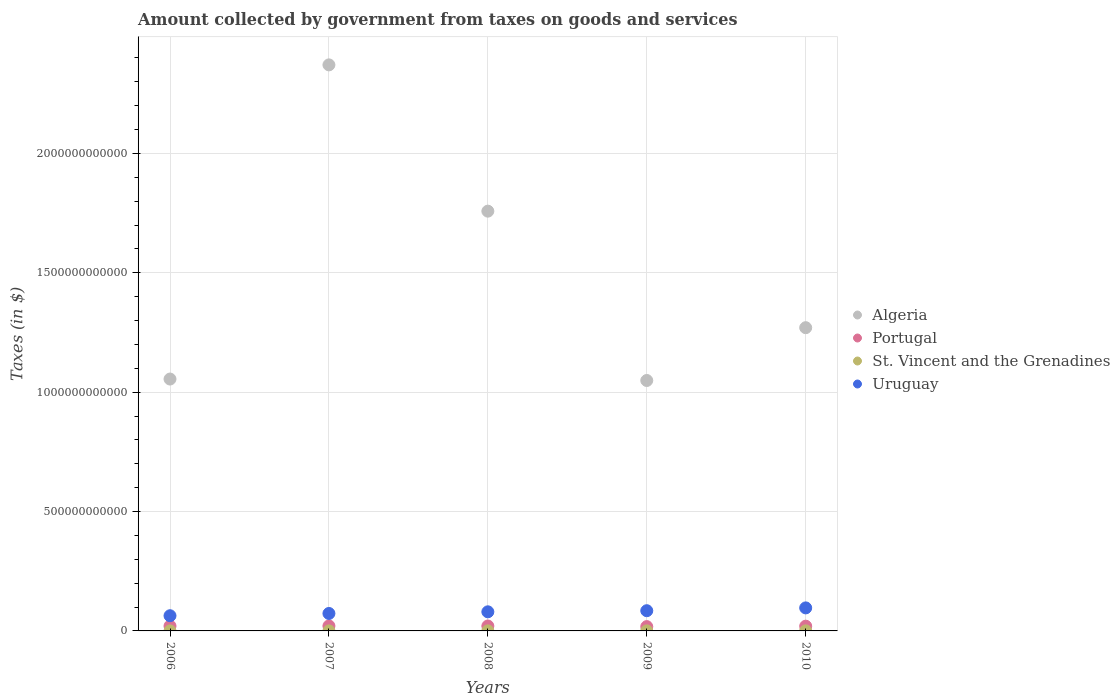How many different coloured dotlines are there?
Offer a terse response. 4. Is the number of dotlines equal to the number of legend labels?
Provide a succinct answer. Yes. What is the amount collected by government from taxes on goods and services in Portugal in 2010?
Provide a succinct answer. 1.99e+1. Across all years, what is the maximum amount collected by government from taxes on goods and services in St. Vincent and the Grenadines?
Provide a short and direct response. 2.46e+08. Across all years, what is the minimum amount collected by government from taxes on goods and services in St. Vincent and the Grenadines?
Give a very brief answer. 9.81e+07. In which year was the amount collected by government from taxes on goods and services in Algeria minimum?
Your answer should be very brief. 2009. What is the total amount collected by government from taxes on goods and services in St. Vincent and the Grenadines in the graph?
Provide a short and direct response. 9.94e+08. What is the difference between the amount collected by government from taxes on goods and services in Algeria in 2006 and that in 2010?
Offer a terse response. -2.15e+11. What is the difference between the amount collected by government from taxes on goods and services in Uruguay in 2007 and the amount collected by government from taxes on goods and services in Algeria in 2008?
Offer a very short reply. -1.69e+12. What is the average amount collected by government from taxes on goods and services in Uruguay per year?
Your answer should be compact. 7.96e+1. In the year 2008, what is the difference between the amount collected by government from taxes on goods and services in Uruguay and amount collected by government from taxes on goods and services in Algeria?
Provide a short and direct response. -1.68e+12. What is the ratio of the amount collected by government from taxes on goods and services in Algeria in 2009 to that in 2010?
Your answer should be very brief. 0.83. Is the difference between the amount collected by government from taxes on goods and services in Uruguay in 2006 and 2007 greater than the difference between the amount collected by government from taxes on goods and services in Algeria in 2006 and 2007?
Make the answer very short. Yes. What is the difference between the highest and the second highest amount collected by government from taxes on goods and services in Portugal?
Offer a terse response. 2.85e+08. What is the difference between the highest and the lowest amount collected by government from taxes on goods and services in St. Vincent and the Grenadines?
Make the answer very short. 1.48e+08. In how many years, is the amount collected by government from taxes on goods and services in St. Vincent and the Grenadines greater than the average amount collected by government from taxes on goods and services in St. Vincent and the Grenadines taken over all years?
Make the answer very short. 3. Does the amount collected by government from taxes on goods and services in Portugal monotonically increase over the years?
Make the answer very short. No. Is the amount collected by government from taxes on goods and services in Algeria strictly greater than the amount collected by government from taxes on goods and services in Uruguay over the years?
Ensure brevity in your answer.  Yes. Is the amount collected by government from taxes on goods and services in Portugal strictly less than the amount collected by government from taxes on goods and services in St. Vincent and the Grenadines over the years?
Your answer should be very brief. No. How many years are there in the graph?
Offer a terse response. 5. What is the difference between two consecutive major ticks on the Y-axis?
Make the answer very short. 5.00e+11. Are the values on the major ticks of Y-axis written in scientific E-notation?
Keep it short and to the point. No. Where does the legend appear in the graph?
Keep it short and to the point. Center right. How many legend labels are there?
Keep it short and to the point. 4. What is the title of the graph?
Offer a terse response. Amount collected by government from taxes on goods and services. What is the label or title of the Y-axis?
Offer a very short reply. Taxes (in $). What is the Taxes (in $) of Algeria in 2006?
Provide a succinct answer. 1.05e+12. What is the Taxes (in $) of Portugal in 2006?
Your answer should be very brief. 2.04e+1. What is the Taxes (in $) in St. Vincent and the Grenadines in 2006?
Your answer should be compact. 9.81e+07. What is the Taxes (in $) of Uruguay in 2006?
Make the answer very short. 6.36e+1. What is the Taxes (in $) of Algeria in 2007?
Make the answer very short. 2.37e+12. What is the Taxes (in $) of Portugal in 2007?
Your response must be concise. 2.09e+1. What is the Taxes (in $) in St. Vincent and the Grenadines in 2007?
Give a very brief answer. 1.85e+08. What is the Taxes (in $) in Uruguay in 2007?
Give a very brief answer. 7.31e+1. What is the Taxes (in $) in Algeria in 2008?
Ensure brevity in your answer.  1.76e+12. What is the Taxes (in $) in Portugal in 2008?
Give a very brief answer. 2.06e+1. What is the Taxes (in $) of St. Vincent and the Grenadines in 2008?
Your answer should be very brief. 2.46e+08. What is the Taxes (in $) of Uruguay in 2008?
Offer a terse response. 8.00e+1. What is the Taxes (in $) in Algeria in 2009?
Ensure brevity in your answer.  1.05e+12. What is the Taxes (in $) of Portugal in 2009?
Ensure brevity in your answer.  1.81e+1. What is the Taxes (in $) in St. Vincent and the Grenadines in 2009?
Ensure brevity in your answer.  2.37e+08. What is the Taxes (in $) of Uruguay in 2009?
Keep it short and to the point. 8.47e+1. What is the Taxes (in $) of Algeria in 2010?
Keep it short and to the point. 1.27e+12. What is the Taxes (in $) of Portugal in 2010?
Keep it short and to the point. 1.99e+1. What is the Taxes (in $) in St. Vincent and the Grenadines in 2010?
Your answer should be very brief. 2.28e+08. What is the Taxes (in $) of Uruguay in 2010?
Provide a short and direct response. 9.64e+1. Across all years, what is the maximum Taxes (in $) of Algeria?
Provide a short and direct response. 2.37e+12. Across all years, what is the maximum Taxes (in $) of Portugal?
Your answer should be very brief. 2.09e+1. Across all years, what is the maximum Taxes (in $) in St. Vincent and the Grenadines?
Ensure brevity in your answer.  2.46e+08. Across all years, what is the maximum Taxes (in $) of Uruguay?
Offer a terse response. 9.64e+1. Across all years, what is the minimum Taxes (in $) of Algeria?
Offer a terse response. 1.05e+12. Across all years, what is the minimum Taxes (in $) of Portugal?
Your answer should be compact. 1.81e+1. Across all years, what is the minimum Taxes (in $) of St. Vincent and the Grenadines?
Keep it short and to the point. 9.81e+07. Across all years, what is the minimum Taxes (in $) of Uruguay?
Your answer should be very brief. 6.36e+1. What is the total Taxes (in $) of Algeria in the graph?
Your answer should be compact. 7.50e+12. What is the total Taxes (in $) of Portugal in the graph?
Your answer should be very brief. 9.99e+1. What is the total Taxes (in $) of St. Vincent and the Grenadines in the graph?
Ensure brevity in your answer.  9.94e+08. What is the total Taxes (in $) of Uruguay in the graph?
Your answer should be compact. 3.98e+11. What is the difference between the Taxes (in $) in Algeria in 2006 and that in 2007?
Give a very brief answer. -1.32e+12. What is the difference between the Taxes (in $) of Portugal in 2006 and that in 2007?
Offer a terse response. -4.60e+08. What is the difference between the Taxes (in $) in St. Vincent and the Grenadines in 2006 and that in 2007?
Your answer should be compact. -8.72e+07. What is the difference between the Taxes (in $) in Uruguay in 2006 and that in 2007?
Provide a succinct answer. -9.46e+09. What is the difference between the Taxes (in $) of Algeria in 2006 and that in 2008?
Ensure brevity in your answer.  -7.03e+11. What is the difference between the Taxes (in $) in Portugal in 2006 and that in 2008?
Ensure brevity in your answer.  -1.75e+08. What is the difference between the Taxes (in $) of St. Vincent and the Grenadines in 2006 and that in 2008?
Keep it short and to the point. -1.48e+08. What is the difference between the Taxes (in $) of Uruguay in 2006 and that in 2008?
Offer a terse response. -1.64e+1. What is the difference between the Taxes (in $) of Algeria in 2006 and that in 2009?
Give a very brief answer. 6.04e+09. What is the difference between the Taxes (in $) of Portugal in 2006 and that in 2009?
Offer a very short reply. 2.35e+09. What is the difference between the Taxes (in $) of St. Vincent and the Grenadines in 2006 and that in 2009?
Ensure brevity in your answer.  -1.39e+08. What is the difference between the Taxes (in $) of Uruguay in 2006 and that in 2009?
Provide a succinct answer. -2.10e+1. What is the difference between the Taxes (in $) of Algeria in 2006 and that in 2010?
Your response must be concise. -2.15e+11. What is the difference between the Taxes (in $) of Portugal in 2006 and that in 2010?
Your answer should be compact. 5.46e+08. What is the difference between the Taxes (in $) in St. Vincent and the Grenadines in 2006 and that in 2010?
Provide a succinct answer. -1.30e+08. What is the difference between the Taxes (in $) of Uruguay in 2006 and that in 2010?
Provide a succinct answer. -3.28e+1. What is the difference between the Taxes (in $) in Algeria in 2007 and that in 2008?
Your answer should be very brief. 6.13e+11. What is the difference between the Taxes (in $) in Portugal in 2007 and that in 2008?
Provide a short and direct response. 2.85e+08. What is the difference between the Taxes (in $) of St. Vincent and the Grenadines in 2007 and that in 2008?
Provide a succinct answer. -6.05e+07. What is the difference between the Taxes (in $) of Uruguay in 2007 and that in 2008?
Your response must be concise. -6.92e+09. What is the difference between the Taxes (in $) of Algeria in 2007 and that in 2009?
Give a very brief answer. 1.32e+12. What is the difference between the Taxes (in $) of Portugal in 2007 and that in 2009?
Your answer should be very brief. 2.81e+09. What is the difference between the Taxes (in $) in St. Vincent and the Grenadines in 2007 and that in 2009?
Give a very brief answer. -5.15e+07. What is the difference between the Taxes (in $) in Uruguay in 2007 and that in 2009?
Offer a terse response. -1.16e+1. What is the difference between the Taxes (in $) in Algeria in 2007 and that in 2010?
Give a very brief answer. 1.10e+12. What is the difference between the Taxes (in $) in Portugal in 2007 and that in 2010?
Offer a very short reply. 1.01e+09. What is the difference between the Taxes (in $) in St. Vincent and the Grenadines in 2007 and that in 2010?
Ensure brevity in your answer.  -4.27e+07. What is the difference between the Taxes (in $) in Uruguay in 2007 and that in 2010?
Your response must be concise. -2.33e+1. What is the difference between the Taxes (in $) of Algeria in 2008 and that in 2009?
Your answer should be compact. 7.09e+11. What is the difference between the Taxes (in $) of Portugal in 2008 and that in 2009?
Give a very brief answer. 2.52e+09. What is the difference between the Taxes (in $) of St. Vincent and the Grenadines in 2008 and that in 2009?
Give a very brief answer. 9.00e+06. What is the difference between the Taxes (in $) in Uruguay in 2008 and that in 2009?
Your response must be concise. -4.65e+09. What is the difference between the Taxes (in $) of Algeria in 2008 and that in 2010?
Give a very brief answer. 4.88e+11. What is the difference between the Taxes (in $) of Portugal in 2008 and that in 2010?
Ensure brevity in your answer.  7.20e+08. What is the difference between the Taxes (in $) in St. Vincent and the Grenadines in 2008 and that in 2010?
Make the answer very short. 1.78e+07. What is the difference between the Taxes (in $) of Uruguay in 2008 and that in 2010?
Keep it short and to the point. -1.64e+1. What is the difference between the Taxes (in $) in Algeria in 2009 and that in 2010?
Keep it short and to the point. -2.21e+11. What is the difference between the Taxes (in $) of Portugal in 2009 and that in 2010?
Offer a terse response. -1.80e+09. What is the difference between the Taxes (in $) of St. Vincent and the Grenadines in 2009 and that in 2010?
Make the answer very short. 8.80e+06. What is the difference between the Taxes (in $) in Uruguay in 2009 and that in 2010?
Offer a very short reply. -1.18e+1. What is the difference between the Taxes (in $) in Algeria in 2006 and the Taxes (in $) in Portugal in 2007?
Ensure brevity in your answer.  1.03e+12. What is the difference between the Taxes (in $) of Algeria in 2006 and the Taxes (in $) of St. Vincent and the Grenadines in 2007?
Provide a short and direct response. 1.05e+12. What is the difference between the Taxes (in $) of Algeria in 2006 and the Taxes (in $) of Uruguay in 2007?
Offer a terse response. 9.82e+11. What is the difference between the Taxes (in $) in Portugal in 2006 and the Taxes (in $) in St. Vincent and the Grenadines in 2007?
Provide a succinct answer. 2.02e+1. What is the difference between the Taxes (in $) in Portugal in 2006 and the Taxes (in $) in Uruguay in 2007?
Offer a terse response. -5.27e+1. What is the difference between the Taxes (in $) in St. Vincent and the Grenadines in 2006 and the Taxes (in $) in Uruguay in 2007?
Provide a short and direct response. -7.30e+1. What is the difference between the Taxes (in $) in Algeria in 2006 and the Taxes (in $) in Portugal in 2008?
Keep it short and to the point. 1.03e+12. What is the difference between the Taxes (in $) of Algeria in 2006 and the Taxes (in $) of St. Vincent and the Grenadines in 2008?
Your answer should be very brief. 1.05e+12. What is the difference between the Taxes (in $) of Algeria in 2006 and the Taxes (in $) of Uruguay in 2008?
Your answer should be compact. 9.75e+11. What is the difference between the Taxes (in $) in Portugal in 2006 and the Taxes (in $) in St. Vincent and the Grenadines in 2008?
Provide a short and direct response. 2.02e+1. What is the difference between the Taxes (in $) in Portugal in 2006 and the Taxes (in $) in Uruguay in 2008?
Offer a very short reply. -5.96e+1. What is the difference between the Taxes (in $) in St. Vincent and the Grenadines in 2006 and the Taxes (in $) in Uruguay in 2008?
Ensure brevity in your answer.  -7.99e+1. What is the difference between the Taxes (in $) in Algeria in 2006 and the Taxes (in $) in Portugal in 2009?
Provide a short and direct response. 1.04e+12. What is the difference between the Taxes (in $) of Algeria in 2006 and the Taxes (in $) of St. Vincent and the Grenadines in 2009?
Offer a terse response. 1.05e+12. What is the difference between the Taxes (in $) in Algeria in 2006 and the Taxes (in $) in Uruguay in 2009?
Provide a short and direct response. 9.70e+11. What is the difference between the Taxes (in $) in Portugal in 2006 and the Taxes (in $) in St. Vincent and the Grenadines in 2009?
Your answer should be compact. 2.02e+1. What is the difference between the Taxes (in $) in Portugal in 2006 and the Taxes (in $) in Uruguay in 2009?
Offer a very short reply. -6.43e+1. What is the difference between the Taxes (in $) in St. Vincent and the Grenadines in 2006 and the Taxes (in $) in Uruguay in 2009?
Ensure brevity in your answer.  -8.46e+1. What is the difference between the Taxes (in $) of Algeria in 2006 and the Taxes (in $) of Portugal in 2010?
Offer a very short reply. 1.04e+12. What is the difference between the Taxes (in $) of Algeria in 2006 and the Taxes (in $) of St. Vincent and the Grenadines in 2010?
Ensure brevity in your answer.  1.05e+12. What is the difference between the Taxes (in $) in Algeria in 2006 and the Taxes (in $) in Uruguay in 2010?
Provide a succinct answer. 9.59e+11. What is the difference between the Taxes (in $) in Portugal in 2006 and the Taxes (in $) in St. Vincent and the Grenadines in 2010?
Provide a short and direct response. 2.02e+1. What is the difference between the Taxes (in $) of Portugal in 2006 and the Taxes (in $) of Uruguay in 2010?
Your response must be concise. -7.60e+1. What is the difference between the Taxes (in $) of St. Vincent and the Grenadines in 2006 and the Taxes (in $) of Uruguay in 2010?
Your answer should be very brief. -9.63e+1. What is the difference between the Taxes (in $) in Algeria in 2007 and the Taxes (in $) in Portugal in 2008?
Keep it short and to the point. 2.35e+12. What is the difference between the Taxes (in $) of Algeria in 2007 and the Taxes (in $) of St. Vincent and the Grenadines in 2008?
Offer a terse response. 2.37e+12. What is the difference between the Taxes (in $) of Algeria in 2007 and the Taxes (in $) of Uruguay in 2008?
Give a very brief answer. 2.29e+12. What is the difference between the Taxes (in $) in Portugal in 2007 and the Taxes (in $) in St. Vincent and the Grenadines in 2008?
Provide a short and direct response. 2.06e+1. What is the difference between the Taxes (in $) in Portugal in 2007 and the Taxes (in $) in Uruguay in 2008?
Your answer should be compact. -5.91e+1. What is the difference between the Taxes (in $) in St. Vincent and the Grenadines in 2007 and the Taxes (in $) in Uruguay in 2008?
Keep it short and to the point. -7.98e+1. What is the difference between the Taxes (in $) of Algeria in 2007 and the Taxes (in $) of Portugal in 2009?
Provide a short and direct response. 2.35e+12. What is the difference between the Taxes (in $) of Algeria in 2007 and the Taxes (in $) of St. Vincent and the Grenadines in 2009?
Ensure brevity in your answer.  2.37e+12. What is the difference between the Taxes (in $) of Algeria in 2007 and the Taxes (in $) of Uruguay in 2009?
Keep it short and to the point. 2.29e+12. What is the difference between the Taxes (in $) of Portugal in 2007 and the Taxes (in $) of St. Vincent and the Grenadines in 2009?
Your response must be concise. 2.06e+1. What is the difference between the Taxes (in $) in Portugal in 2007 and the Taxes (in $) in Uruguay in 2009?
Offer a very short reply. -6.38e+1. What is the difference between the Taxes (in $) in St. Vincent and the Grenadines in 2007 and the Taxes (in $) in Uruguay in 2009?
Provide a succinct answer. -8.45e+1. What is the difference between the Taxes (in $) of Algeria in 2007 and the Taxes (in $) of Portugal in 2010?
Provide a short and direct response. 2.35e+12. What is the difference between the Taxes (in $) of Algeria in 2007 and the Taxes (in $) of St. Vincent and the Grenadines in 2010?
Offer a terse response. 2.37e+12. What is the difference between the Taxes (in $) in Algeria in 2007 and the Taxes (in $) in Uruguay in 2010?
Make the answer very short. 2.27e+12. What is the difference between the Taxes (in $) of Portugal in 2007 and the Taxes (in $) of St. Vincent and the Grenadines in 2010?
Provide a short and direct response. 2.07e+1. What is the difference between the Taxes (in $) in Portugal in 2007 and the Taxes (in $) in Uruguay in 2010?
Ensure brevity in your answer.  -7.56e+1. What is the difference between the Taxes (in $) in St. Vincent and the Grenadines in 2007 and the Taxes (in $) in Uruguay in 2010?
Provide a succinct answer. -9.62e+1. What is the difference between the Taxes (in $) in Algeria in 2008 and the Taxes (in $) in Portugal in 2009?
Your answer should be compact. 1.74e+12. What is the difference between the Taxes (in $) in Algeria in 2008 and the Taxes (in $) in St. Vincent and the Grenadines in 2009?
Your answer should be very brief. 1.76e+12. What is the difference between the Taxes (in $) in Algeria in 2008 and the Taxes (in $) in Uruguay in 2009?
Your answer should be very brief. 1.67e+12. What is the difference between the Taxes (in $) in Portugal in 2008 and the Taxes (in $) in St. Vincent and the Grenadines in 2009?
Offer a terse response. 2.04e+1. What is the difference between the Taxes (in $) in Portugal in 2008 and the Taxes (in $) in Uruguay in 2009?
Keep it short and to the point. -6.41e+1. What is the difference between the Taxes (in $) in St. Vincent and the Grenadines in 2008 and the Taxes (in $) in Uruguay in 2009?
Offer a very short reply. -8.44e+1. What is the difference between the Taxes (in $) in Algeria in 2008 and the Taxes (in $) in Portugal in 2010?
Provide a succinct answer. 1.74e+12. What is the difference between the Taxes (in $) of Algeria in 2008 and the Taxes (in $) of St. Vincent and the Grenadines in 2010?
Your answer should be very brief. 1.76e+12. What is the difference between the Taxes (in $) of Algeria in 2008 and the Taxes (in $) of Uruguay in 2010?
Offer a very short reply. 1.66e+12. What is the difference between the Taxes (in $) of Portugal in 2008 and the Taxes (in $) of St. Vincent and the Grenadines in 2010?
Offer a very short reply. 2.04e+1. What is the difference between the Taxes (in $) of Portugal in 2008 and the Taxes (in $) of Uruguay in 2010?
Offer a terse response. -7.58e+1. What is the difference between the Taxes (in $) in St. Vincent and the Grenadines in 2008 and the Taxes (in $) in Uruguay in 2010?
Your answer should be very brief. -9.62e+1. What is the difference between the Taxes (in $) in Algeria in 2009 and the Taxes (in $) in Portugal in 2010?
Provide a short and direct response. 1.03e+12. What is the difference between the Taxes (in $) in Algeria in 2009 and the Taxes (in $) in St. Vincent and the Grenadines in 2010?
Your answer should be compact. 1.05e+12. What is the difference between the Taxes (in $) of Algeria in 2009 and the Taxes (in $) of Uruguay in 2010?
Your response must be concise. 9.53e+11. What is the difference between the Taxes (in $) of Portugal in 2009 and the Taxes (in $) of St. Vincent and the Grenadines in 2010?
Your answer should be compact. 1.78e+1. What is the difference between the Taxes (in $) in Portugal in 2009 and the Taxes (in $) in Uruguay in 2010?
Your answer should be compact. -7.84e+1. What is the difference between the Taxes (in $) of St. Vincent and the Grenadines in 2009 and the Taxes (in $) of Uruguay in 2010?
Offer a terse response. -9.62e+1. What is the average Taxes (in $) of Algeria per year?
Keep it short and to the point. 1.50e+12. What is the average Taxes (in $) in Portugal per year?
Make the answer very short. 2.00e+1. What is the average Taxes (in $) in St. Vincent and the Grenadines per year?
Ensure brevity in your answer.  1.99e+08. What is the average Taxes (in $) of Uruguay per year?
Your answer should be compact. 7.96e+1. In the year 2006, what is the difference between the Taxes (in $) of Algeria and Taxes (in $) of Portugal?
Ensure brevity in your answer.  1.03e+12. In the year 2006, what is the difference between the Taxes (in $) in Algeria and Taxes (in $) in St. Vincent and the Grenadines?
Your answer should be very brief. 1.05e+12. In the year 2006, what is the difference between the Taxes (in $) of Algeria and Taxes (in $) of Uruguay?
Provide a short and direct response. 9.91e+11. In the year 2006, what is the difference between the Taxes (in $) of Portugal and Taxes (in $) of St. Vincent and the Grenadines?
Make the answer very short. 2.03e+1. In the year 2006, what is the difference between the Taxes (in $) of Portugal and Taxes (in $) of Uruguay?
Your answer should be compact. -4.32e+1. In the year 2006, what is the difference between the Taxes (in $) in St. Vincent and the Grenadines and Taxes (in $) in Uruguay?
Offer a very short reply. -6.36e+1. In the year 2007, what is the difference between the Taxes (in $) of Algeria and Taxes (in $) of Portugal?
Provide a short and direct response. 2.35e+12. In the year 2007, what is the difference between the Taxes (in $) in Algeria and Taxes (in $) in St. Vincent and the Grenadines?
Offer a very short reply. 2.37e+12. In the year 2007, what is the difference between the Taxes (in $) in Algeria and Taxes (in $) in Uruguay?
Provide a succinct answer. 2.30e+12. In the year 2007, what is the difference between the Taxes (in $) in Portugal and Taxes (in $) in St. Vincent and the Grenadines?
Your response must be concise. 2.07e+1. In the year 2007, what is the difference between the Taxes (in $) of Portugal and Taxes (in $) of Uruguay?
Give a very brief answer. -5.22e+1. In the year 2007, what is the difference between the Taxes (in $) in St. Vincent and the Grenadines and Taxes (in $) in Uruguay?
Your response must be concise. -7.29e+1. In the year 2008, what is the difference between the Taxes (in $) in Algeria and Taxes (in $) in Portugal?
Make the answer very short. 1.74e+12. In the year 2008, what is the difference between the Taxes (in $) of Algeria and Taxes (in $) of St. Vincent and the Grenadines?
Your answer should be very brief. 1.76e+12. In the year 2008, what is the difference between the Taxes (in $) in Algeria and Taxes (in $) in Uruguay?
Ensure brevity in your answer.  1.68e+12. In the year 2008, what is the difference between the Taxes (in $) in Portugal and Taxes (in $) in St. Vincent and the Grenadines?
Provide a succinct answer. 2.04e+1. In the year 2008, what is the difference between the Taxes (in $) of Portugal and Taxes (in $) of Uruguay?
Your response must be concise. -5.94e+1. In the year 2008, what is the difference between the Taxes (in $) in St. Vincent and the Grenadines and Taxes (in $) in Uruguay?
Your answer should be compact. -7.98e+1. In the year 2009, what is the difference between the Taxes (in $) in Algeria and Taxes (in $) in Portugal?
Give a very brief answer. 1.03e+12. In the year 2009, what is the difference between the Taxes (in $) of Algeria and Taxes (in $) of St. Vincent and the Grenadines?
Ensure brevity in your answer.  1.05e+12. In the year 2009, what is the difference between the Taxes (in $) of Algeria and Taxes (in $) of Uruguay?
Your response must be concise. 9.64e+11. In the year 2009, what is the difference between the Taxes (in $) in Portugal and Taxes (in $) in St. Vincent and the Grenadines?
Offer a terse response. 1.78e+1. In the year 2009, what is the difference between the Taxes (in $) of Portugal and Taxes (in $) of Uruguay?
Offer a very short reply. -6.66e+1. In the year 2009, what is the difference between the Taxes (in $) of St. Vincent and the Grenadines and Taxes (in $) of Uruguay?
Give a very brief answer. -8.44e+1. In the year 2010, what is the difference between the Taxes (in $) of Algeria and Taxes (in $) of Portugal?
Give a very brief answer. 1.25e+12. In the year 2010, what is the difference between the Taxes (in $) of Algeria and Taxes (in $) of St. Vincent and the Grenadines?
Offer a very short reply. 1.27e+12. In the year 2010, what is the difference between the Taxes (in $) in Algeria and Taxes (in $) in Uruguay?
Give a very brief answer. 1.17e+12. In the year 2010, what is the difference between the Taxes (in $) of Portugal and Taxes (in $) of St. Vincent and the Grenadines?
Offer a very short reply. 1.96e+1. In the year 2010, what is the difference between the Taxes (in $) of Portugal and Taxes (in $) of Uruguay?
Make the answer very short. -7.66e+1. In the year 2010, what is the difference between the Taxes (in $) in St. Vincent and the Grenadines and Taxes (in $) in Uruguay?
Provide a short and direct response. -9.62e+1. What is the ratio of the Taxes (in $) of Algeria in 2006 to that in 2007?
Give a very brief answer. 0.45. What is the ratio of the Taxes (in $) of Portugal in 2006 to that in 2007?
Your answer should be very brief. 0.98. What is the ratio of the Taxes (in $) in St. Vincent and the Grenadines in 2006 to that in 2007?
Your answer should be compact. 0.53. What is the ratio of the Taxes (in $) in Uruguay in 2006 to that in 2007?
Ensure brevity in your answer.  0.87. What is the ratio of the Taxes (in $) in Portugal in 2006 to that in 2008?
Offer a very short reply. 0.99. What is the ratio of the Taxes (in $) in St. Vincent and the Grenadines in 2006 to that in 2008?
Provide a short and direct response. 0.4. What is the ratio of the Taxes (in $) of Uruguay in 2006 to that in 2008?
Your response must be concise. 0.8. What is the ratio of the Taxes (in $) of Portugal in 2006 to that in 2009?
Your answer should be very brief. 1.13. What is the ratio of the Taxes (in $) of St. Vincent and the Grenadines in 2006 to that in 2009?
Provide a short and direct response. 0.41. What is the ratio of the Taxes (in $) in Uruguay in 2006 to that in 2009?
Provide a short and direct response. 0.75. What is the ratio of the Taxes (in $) in Algeria in 2006 to that in 2010?
Your answer should be compact. 0.83. What is the ratio of the Taxes (in $) in Portugal in 2006 to that in 2010?
Keep it short and to the point. 1.03. What is the ratio of the Taxes (in $) in St. Vincent and the Grenadines in 2006 to that in 2010?
Your answer should be compact. 0.43. What is the ratio of the Taxes (in $) of Uruguay in 2006 to that in 2010?
Your answer should be very brief. 0.66. What is the ratio of the Taxes (in $) in Algeria in 2007 to that in 2008?
Your answer should be compact. 1.35. What is the ratio of the Taxes (in $) of Portugal in 2007 to that in 2008?
Your answer should be compact. 1.01. What is the ratio of the Taxes (in $) of St. Vincent and the Grenadines in 2007 to that in 2008?
Give a very brief answer. 0.75. What is the ratio of the Taxes (in $) of Uruguay in 2007 to that in 2008?
Offer a very short reply. 0.91. What is the ratio of the Taxes (in $) of Algeria in 2007 to that in 2009?
Ensure brevity in your answer.  2.26. What is the ratio of the Taxes (in $) of Portugal in 2007 to that in 2009?
Offer a very short reply. 1.16. What is the ratio of the Taxes (in $) of St. Vincent and the Grenadines in 2007 to that in 2009?
Provide a short and direct response. 0.78. What is the ratio of the Taxes (in $) of Uruguay in 2007 to that in 2009?
Your response must be concise. 0.86. What is the ratio of the Taxes (in $) of Algeria in 2007 to that in 2010?
Offer a very short reply. 1.87. What is the ratio of the Taxes (in $) in Portugal in 2007 to that in 2010?
Give a very brief answer. 1.05. What is the ratio of the Taxes (in $) in St. Vincent and the Grenadines in 2007 to that in 2010?
Your response must be concise. 0.81. What is the ratio of the Taxes (in $) of Uruguay in 2007 to that in 2010?
Offer a terse response. 0.76. What is the ratio of the Taxes (in $) in Algeria in 2008 to that in 2009?
Provide a succinct answer. 1.68. What is the ratio of the Taxes (in $) in Portugal in 2008 to that in 2009?
Give a very brief answer. 1.14. What is the ratio of the Taxes (in $) of St. Vincent and the Grenadines in 2008 to that in 2009?
Your response must be concise. 1.04. What is the ratio of the Taxes (in $) of Uruguay in 2008 to that in 2009?
Provide a short and direct response. 0.95. What is the ratio of the Taxes (in $) of Algeria in 2008 to that in 2010?
Your response must be concise. 1.38. What is the ratio of the Taxes (in $) in Portugal in 2008 to that in 2010?
Offer a very short reply. 1.04. What is the ratio of the Taxes (in $) in St. Vincent and the Grenadines in 2008 to that in 2010?
Provide a short and direct response. 1.08. What is the ratio of the Taxes (in $) in Uruguay in 2008 to that in 2010?
Your answer should be very brief. 0.83. What is the ratio of the Taxes (in $) in Algeria in 2009 to that in 2010?
Offer a very short reply. 0.83. What is the ratio of the Taxes (in $) in Portugal in 2009 to that in 2010?
Offer a very short reply. 0.91. What is the ratio of the Taxes (in $) of St. Vincent and the Grenadines in 2009 to that in 2010?
Provide a short and direct response. 1.04. What is the ratio of the Taxes (in $) in Uruguay in 2009 to that in 2010?
Make the answer very short. 0.88. What is the difference between the highest and the second highest Taxes (in $) of Algeria?
Keep it short and to the point. 6.13e+11. What is the difference between the highest and the second highest Taxes (in $) in Portugal?
Offer a terse response. 2.85e+08. What is the difference between the highest and the second highest Taxes (in $) of St. Vincent and the Grenadines?
Provide a short and direct response. 9.00e+06. What is the difference between the highest and the second highest Taxes (in $) in Uruguay?
Offer a very short reply. 1.18e+1. What is the difference between the highest and the lowest Taxes (in $) of Algeria?
Your answer should be compact. 1.32e+12. What is the difference between the highest and the lowest Taxes (in $) in Portugal?
Provide a succinct answer. 2.81e+09. What is the difference between the highest and the lowest Taxes (in $) of St. Vincent and the Grenadines?
Give a very brief answer. 1.48e+08. What is the difference between the highest and the lowest Taxes (in $) of Uruguay?
Offer a very short reply. 3.28e+1. 